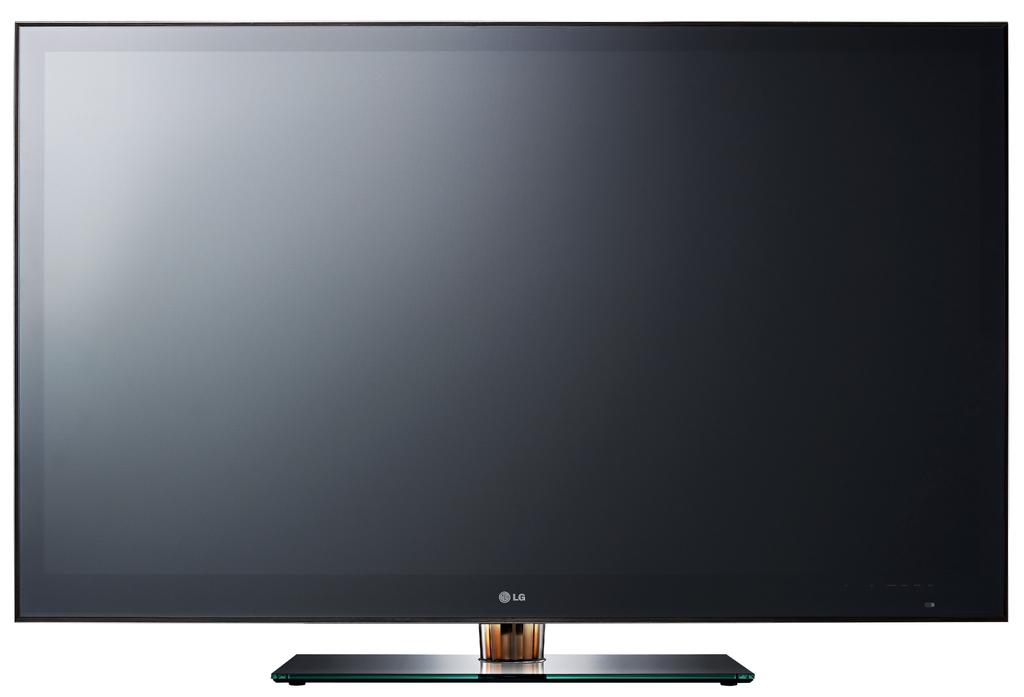<image>
Provide a brief description of the given image. LG computer monitor that is not turned on 